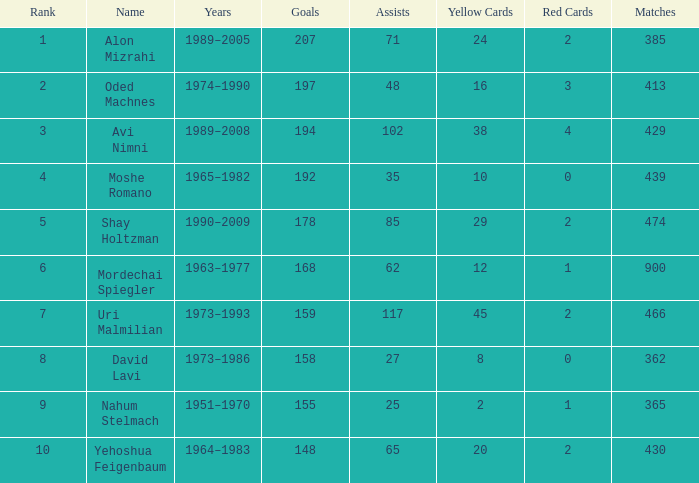What is the Rank of the player with 158 Goals in more than 362 Matches? 0.0. 